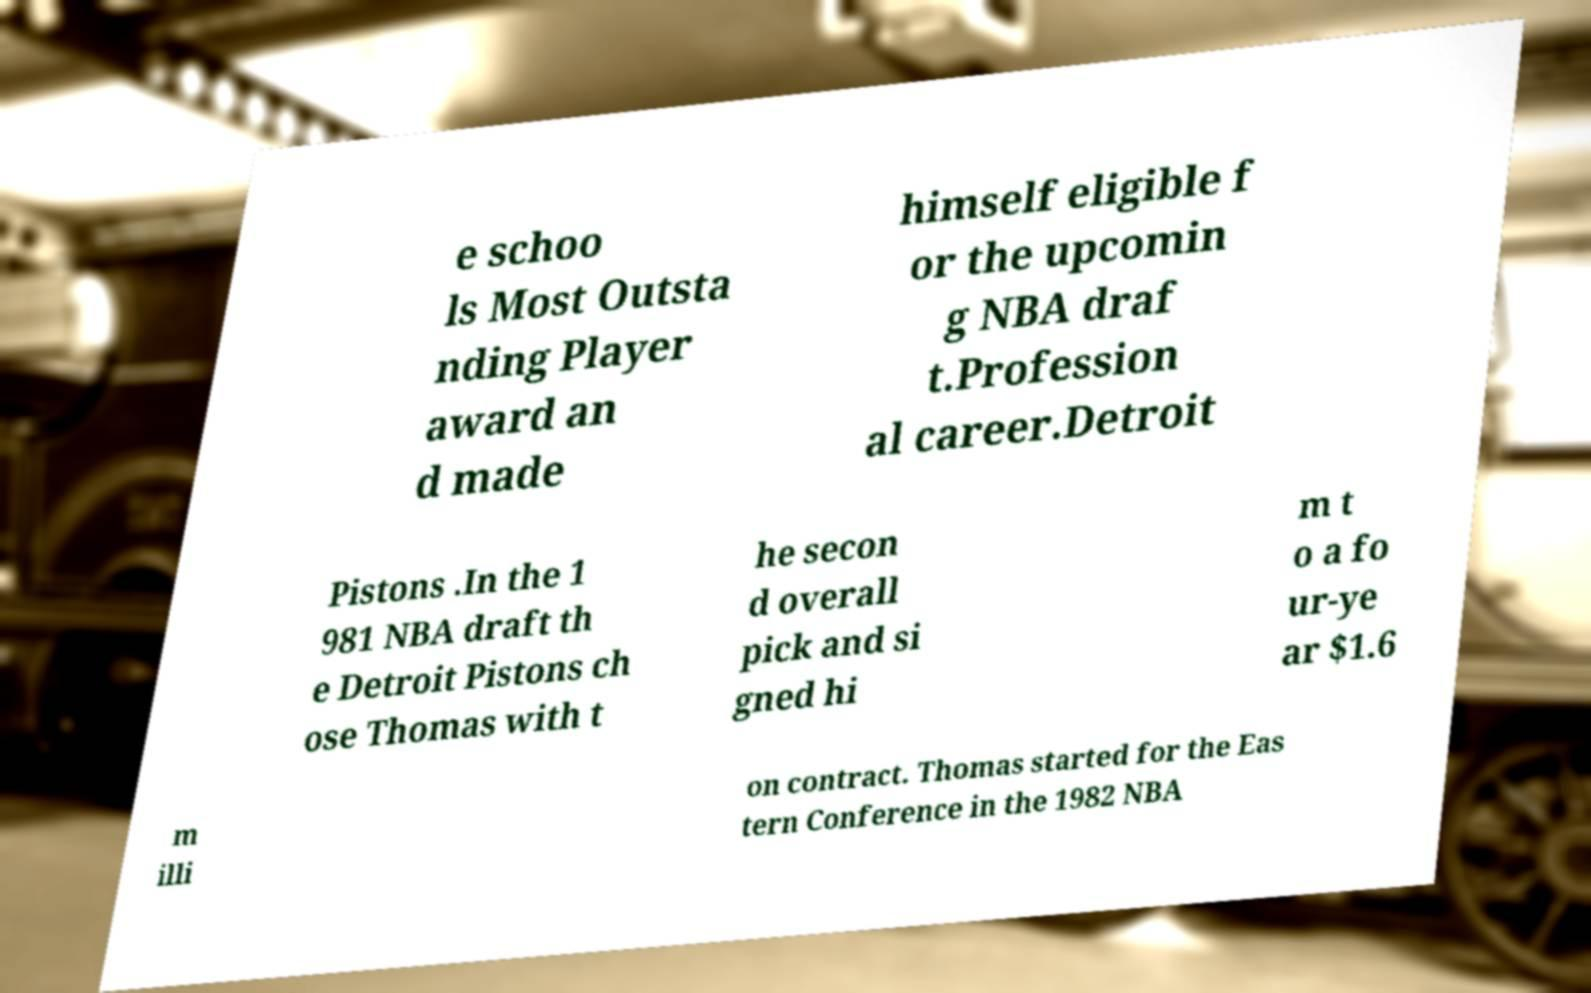What messages or text are displayed in this image? I need them in a readable, typed format. e schoo ls Most Outsta nding Player award an d made himself eligible f or the upcomin g NBA draf t.Profession al career.Detroit Pistons .In the 1 981 NBA draft th e Detroit Pistons ch ose Thomas with t he secon d overall pick and si gned hi m t o a fo ur-ye ar $1.6 m illi on contract. Thomas started for the Eas tern Conference in the 1982 NBA 